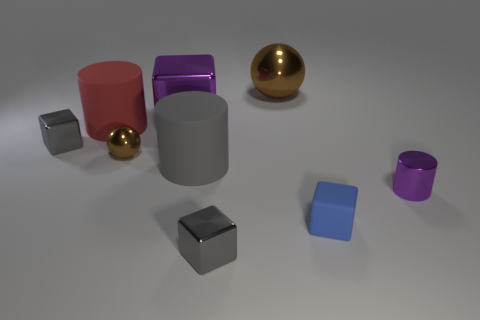Add 1 tiny metallic cylinders. How many objects exist? 10 Subtract all cylinders. How many objects are left? 6 Add 2 metallic balls. How many metallic balls are left? 4 Add 9 small green metallic balls. How many small green metallic balls exist? 9 Subtract 1 purple cubes. How many objects are left? 8 Subtract all small blocks. Subtract all purple things. How many objects are left? 4 